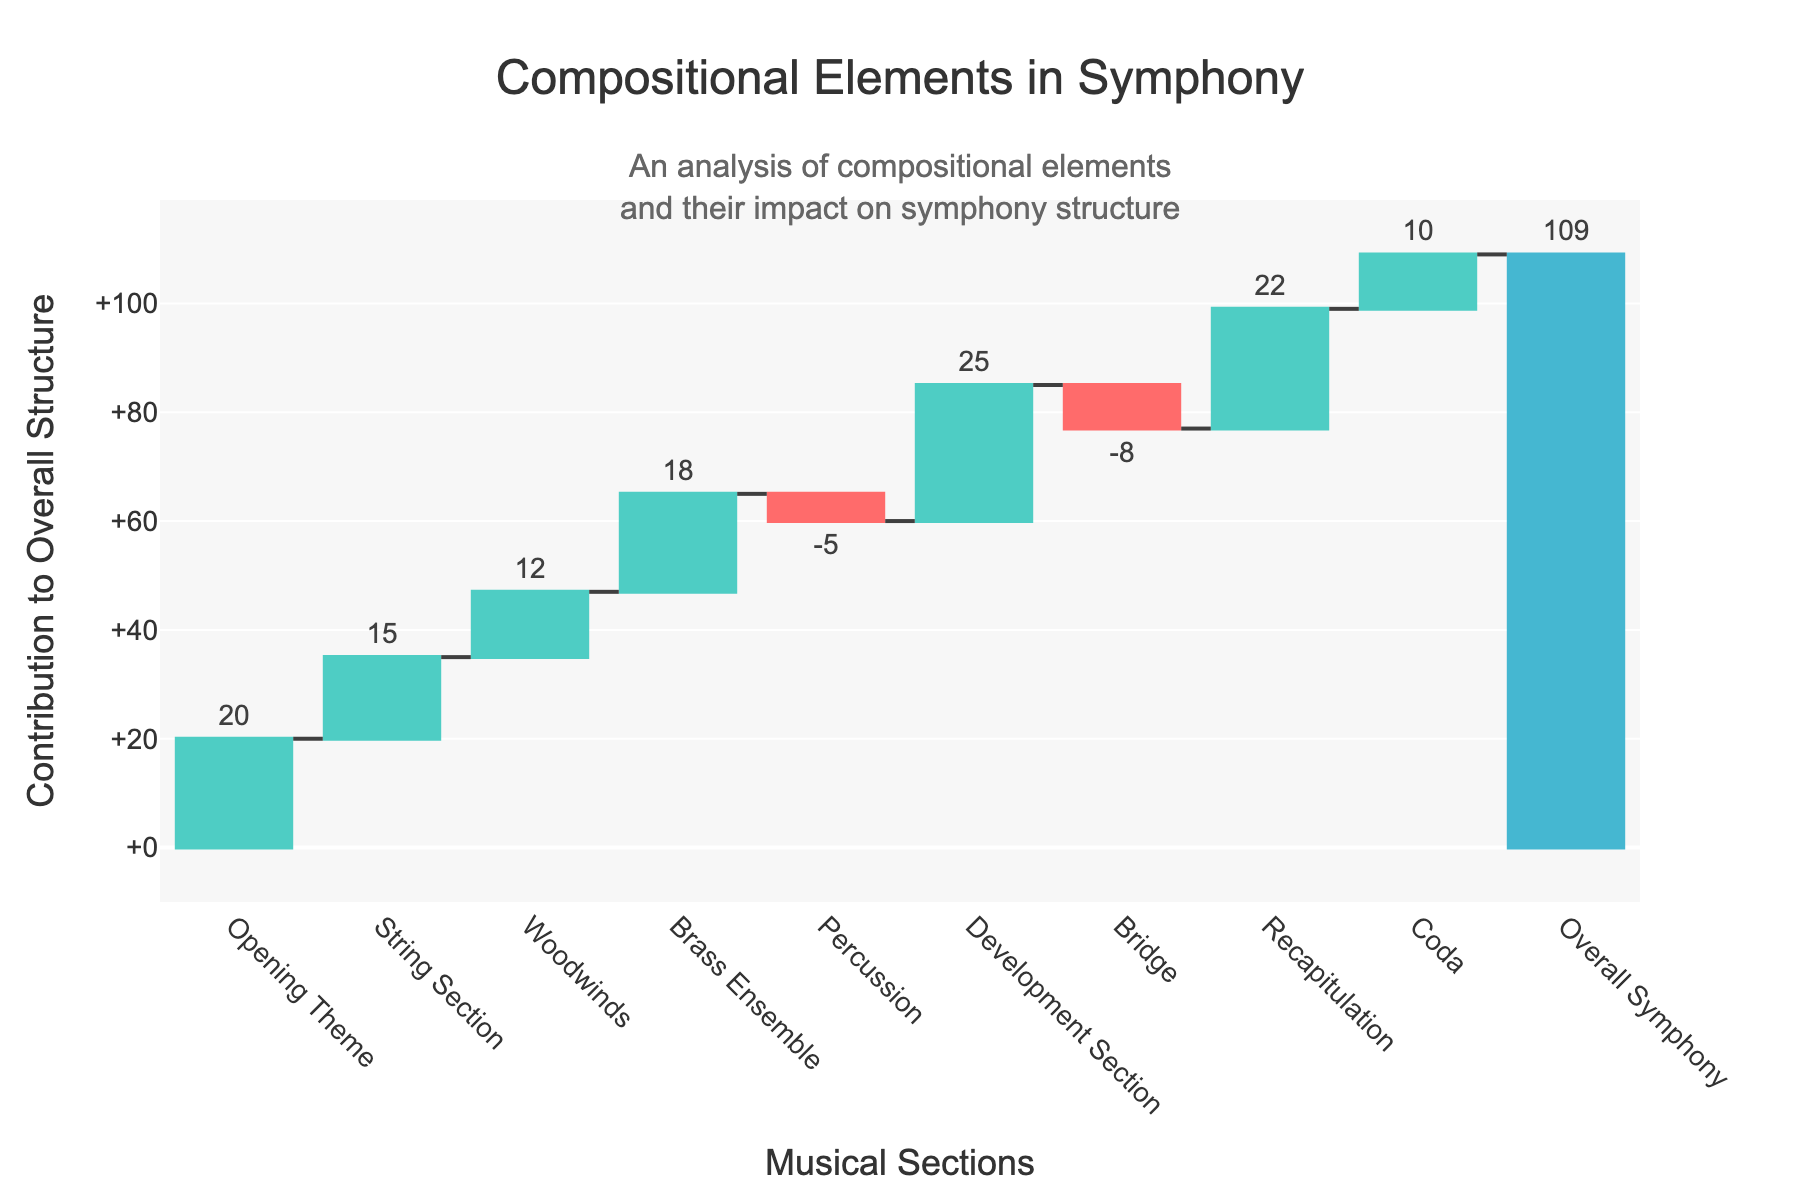What's the title of the chart? The title can be found at the top of the figure in a larger font size. It helps in understanding what the chart is about.
Answer: Compositional Elements in Symphony What's the contribution value of the Development Section? Locate the bar labeled "Development Section" and read the number next to it to determine its contribution value.
Answer: 25 Which section has the most negative contribution? Look for the bar with the most negative value on the chart. Compare the negative contributions to identify the largest one.
Answer: Bridge What is the total contribution of all musical sections excluding the Overall Symphony? Sum all the individual contributions (20 + 15 + 12 + 18 - 5 + 25 - 8 + 22 + 10) to find the total.
Answer: 109 How does the contribution of the Brass Ensemble compare to the Woodwinds? Compare the heights of the bars labeled "Brass Ensemble" and "Woodwinds" and read the values.
Answer: Brass Ensemble has a higher contribution (18 vs 12) What is the net effect of Percussion and Bridge on the symphony? Add the contributions of Percussion and Bridge, taking into account their negative values (-5 and -8 respectively). The net effect is -13.
Answer: -13 Which section follows the Opening Theme in the figure? Look at the bar immediately to the right of the "Opening Theme" bar.
Answer: String Section Is the recapitulation section's contribution higher or lower than the String Section's? Compare the values of the bars labeled "Recapitulation" and "String Section".
Answer: Higher How many sections contribute positively to the overall structure? Count the number of bars with positive contribution values.
Answer: 7 What can be inferred about the overall structure of the symphony considering the individual contributions? By summing all individual contributions, you see they add up to the overall value of 109, showing each section's impact.
Answer: Individual contributions combine to form the overall structure of 109 